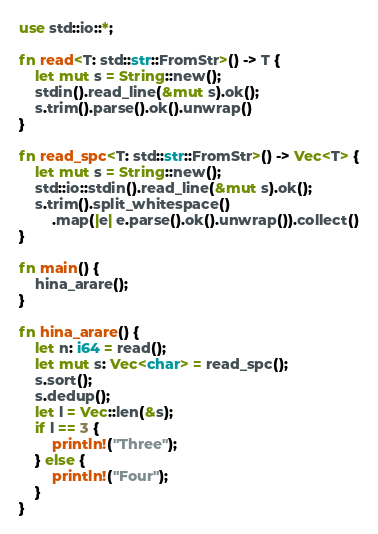Convert code to text. <code><loc_0><loc_0><loc_500><loc_500><_Rust_>use std::io::*;

fn read<T: std::str::FromStr>() -> T {
    let mut s = String::new();
    stdin().read_line(&mut s).ok();
    s.trim().parse().ok().unwrap()
}
 
fn read_spc<T: std::str::FromStr>() -> Vec<T> {
    let mut s = String::new();
    std::io::stdin().read_line(&mut s).ok();
    s.trim().split_whitespace()
        .map(|e| e.parse().ok().unwrap()).collect()
}

fn main() {
    hina_arare();
}

fn hina_arare() {
    let n: i64 = read();
    let mut s: Vec<char> = read_spc();
    s.sort();
    s.dedup();
    let l = Vec::len(&s);
    if l == 3 {
        println!("Three");
    } else {
        println!("Four");
    }
}</code> 